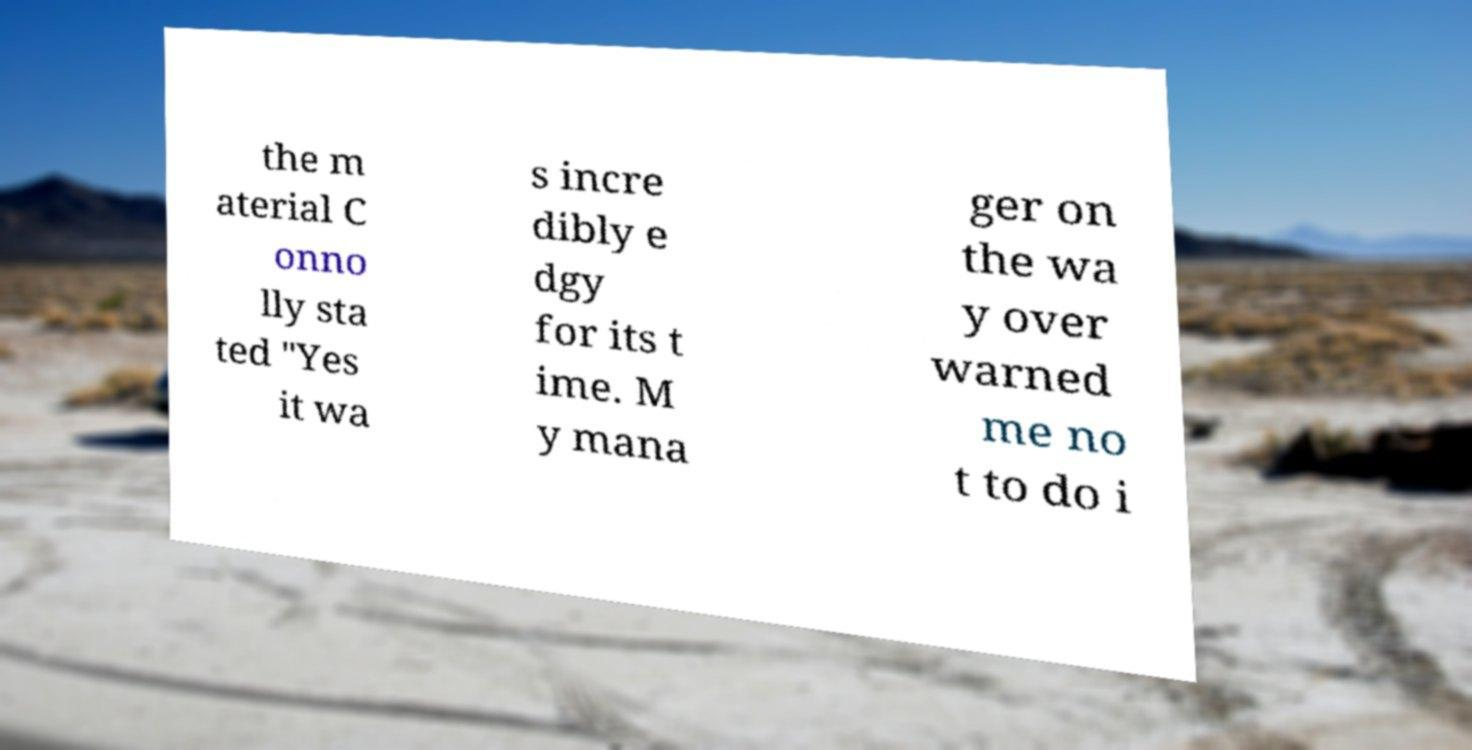Please read and relay the text visible in this image. What does it say? the m aterial C onno lly sta ted "Yes it wa s incre dibly e dgy for its t ime. M y mana ger on the wa y over warned me no t to do i 